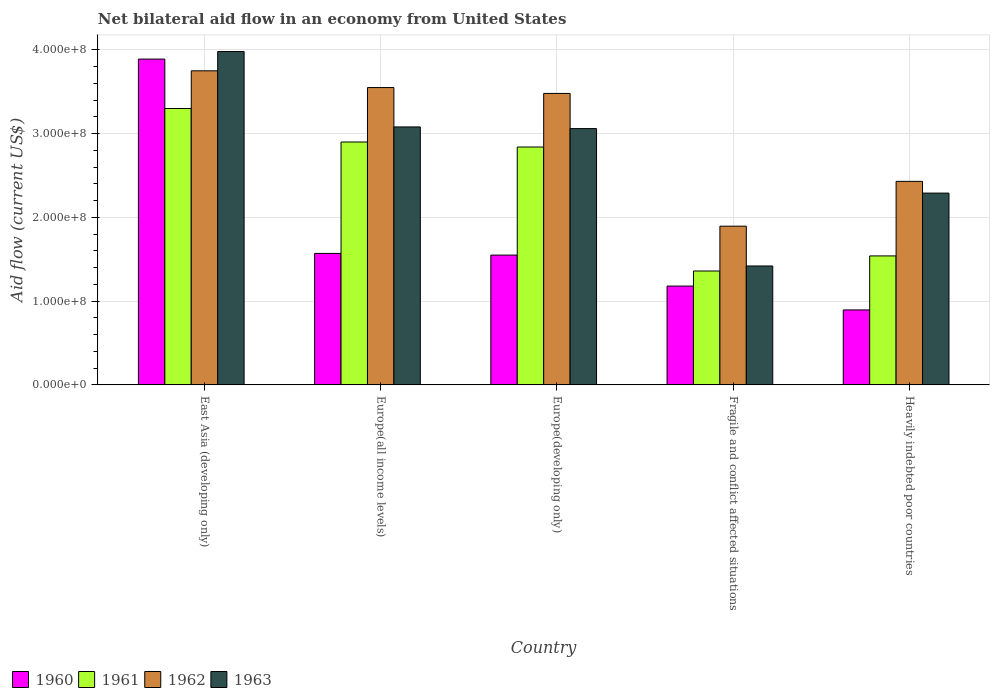How many different coloured bars are there?
Offer a very short reply. 4. How many groups of bars are there?
Keep it short and to the point. 5. Are the number of bars per tick equal to the number of legend labels?
Offer a terse response. Yes. Are the number of bars on each tick of the X-axis equal?
Keep it short and to the point. Yes. How many bars are there on the 1st tick from the left?
Make the answer very short. 4. How many bars are there on the 2nd tick from the right?
Ensure brevity in your answer.  4. What is the label of the 4th group of bars from the left?
Your answer should be very brief. Fragile and conflict affected situations. What is the net bilateral aid flow in 1961 in Europe(developing only)?
Your response must be concise. 2.84e+08. Across all countries, what is the maximum net bilateral aid flow in 1963?
Make the answer very short. 3.98e+08. Across all countries, what is the minimum net bilateral aid flow in 1963?
Provide a succinct answer. 1.42e+08. In which country was the net bilateral aid flow in 1962 maximum?
Make the answer very short. East Asia (developing only). In which country was the net bilateral aid flow in 1960 minimum?
Your response must be concise. Heavily indebted poor countries. What is the total net bilateral aid flow in 1960 in the graph?
Keep it short and to the point. 9.09e+08. What is the difference between the net bilateral aid flow in 1963 in Europe(developing only) and that in Heavily indebted poor countries?
Ensure brevity in your answer.  7.70e+07. What is the difference between the net bilateral aid flow in 1960 in Heavily indebted poor countries and the net bilateral aid flow in 1963 in Europe(developing only)?
Provide a succinct answer. -2.16e+08. What is the average net bilateral aid flow in 1962 per country?
Provide a succinct answer. 3.02e+08. What is the difference between the net bilateral aid flow of/in 1961 and net bilateral aid flow of/in 1960 in Europe(all income levels)?
Ensure brevity in your answer.  1.33e+08. What is the ratio of the net bilateral aid flow in 1961 in Europe(all income levels) to that in Europe(developing only)?
Offer a very short reply. 1.02. Is the difference between the net bilateral aid flow in 1961 in East Asia (developing only) and Heavily indebted poor countries greater than the difference between the net bilateral aid flow in 1960 in East Asia (developing only) and Heavily indebted poor countries?
Offer a very short reply. No. What is the difference between the highest and the second highest net bilateral aid flow in 1961?
Your response must be concise. 4.60e+07. What is the difference between the highest and the lowest net bilateral aid flow in 1963?
Make the answer very short. 2.56e+08. Is the sum of the net bilateral aid flow in 1962 in Europe(all income levels) and Fragile and conflict affected situations greater than the maximum net bilateral aid flow in 1961 across all countries?
Your answer should be compact. Yes. Is it the case that in every country, the sum of the net bilateral aid flow in 1963 and net bilateral aid flow in 1960 is greater than the sum of net bilateral aid flow in 1961 and net bilateral aid flow in 1962?
Keep it short and to the point. No. What does the 3rd bar from the right in Europe(all income levels) represents?
Your answer should be compact. 1961. How many bars are there?
Make the answer very short. 20. Are all the bars in the graph horizontal?
Ensure brevity in your answer.  No. What is the difference between two consecutive major ticks on the Y-axis?
Offer a very short reply. 1.00e+08. Are the values on the major ticks of Y-axis written in scientific E-notation?
Give a very brief answer. Yes. Does the graph contain any zero values?
Provide a short and direct response. No. Does the graph contain grids?
Provide a short and direct response. Yes. Where does the legend appear in the graph?
Offer a very short reply. Bottom left. What is the title of the graph?
Ensure brevity in your answer.  Net bilateral aid flow in an economy from United States. Does "1974" appear as one of the legend labels in the graph?
Give a very brief answer. No. What is the label or title of the X-axis?
Your response must be concise. Country. What is the Aid flow (current US$) of 1960 in East Asia (developing only)?
Ensure brevity in your answer.  3.89e+08. What is the Aid flow (current US$) of 1961 in East Asia (developing only)?
Your answer should be compact. 3.30e+08. What is the Aid flow (current US$) of 1962 in East Asia (developing only)?
Make the answer very short. 3.75e+08. What is the Aid flow (current US$) in 1963 in East Asia (developing only)?
Provide a succinct answer. 3.98e+08. What is the Aid flow (current US$) in 1960 in Europe(all income levels)?
Offer a terse response. 1.57e+08. What is the Aid flow (current US$) in 1961 in Europe(all income levels)?
Your answer should be very brief. 2.90e+08. What is the Aid flow (current US$) in 1962 in Europe(all income levels)?
Your answer should be very brief. 3.55e+08. What is the Aid flow (current US$) of 1963 in Europe(all income levels)?
Provide a short and direct response. 3.08e+08. What is the Aid flow (current US$) of 1960 in Europe(developing only)?
Ensure brevity in your answer.  1.55e+08. What is the Aid flow (current US$) in 1961 in Europe(developing only)?
Your response must be concise. 2.84e+08. What is the Aid flow (current US$) in 1962 in Europe(developing only)?
Offer a terse response. 3.48e+08. What is the Aid flow (current US$) in 1963 in Europe(developing only)?
Keep it short and to the point. 3.06e+08. What is the Aid flow (current US$) in 1960 in Fragile and conflict affected situations?
Ensure brevity in your answer.  1.18e+08. What is the Aid flow (current US$) of 1961 in Fragile and conflict affected situations?
Provide a short and direct response. 1.36e+08. What is the Aid flow (current US$) of 1962 in Fragile and conflict affected situations?
Your response must be concise. 1.90e+08. What is the Aid flow (current US$) of 1963 in Fragile and conflict affected situations?
Provide a succinct answer. 1.42e+08. What is the Aid flow (current US$) in 1960 in Heavily indebted poor countries?
Ensure brevity in your answer.  8.95e+07. What is the Aid flow (current US$) in 1961 in Heavily indebted poor countries?
Provide a short and direct response. 1.54e+08. What is the Aid flow (current US$) of 1962 in Heavily indebted poor countries?
Offer a terse response. 2.43e+08. What is the Aid flow (current US$) in 1963 in Heavily indebted poor countries?
Make the answer very short. 2.29e+08. Across all countries, what is the maximum Aid flow (current US$) of 1960?
Provide a succinct answer. 3.89e+08. Across all countries, what is the maximum Aid flow (current US$) of 1961?
Your answer should be compact. 3.30e+08. Across all countries, what is the maximum Aid flow (current US$) in 1962?
Your answer should be compact. 3.75e+08. Across all countries, what is the maximum Aid flow (current US$) of 1963?
Make the answer very short. 3.98e+08. Across all countries, what is the minimum Aid flow (current US$) in 1960?
Your answer should be very brief. 8.95e+07. Across all countries, what is the minimum Aid flow (current US$) in 1961?
Offer a terse response. 1.36e+08. Across all countries, what is the minimum Aid flow (current US$) in 1962?
Offer a terse response. 1.90e+08. Across all countries, what is the minimum Aid flow (current US$) in 1963?
Your answer should be compact. 1.42e+08. What is the total Aid flow (current US$) in 1960 in the graph?
Make the answer very short. 9.09e+08. What is the total Aid flow (current US$) of 1961 in the graph?
Your response must be concise. 1.19e+09. What is the total Aid flow (current US$) in 1962 in the graph?
Your response must be concise. 1.51e+09. What is the total Aid flow (current US$) in 1963 in the graph?
Give a very brief answer. 1.38e+09. What is the difference between the Aid flow (current US$) in 1960 in East Asia (developing only) and that in Europe(all income levels)?
Your response must be concise. 2.32e+08. What is the difference between the Aid flow (current US$) of 1961 in East Asia (developing only) and that in Europe(all income levels)?
Provide a short and direct response. 4.00e+07. What is the difference between the Aid flow (current US$) of 1962 in East Asia (developing only) and that in Europe(all income levels)?
Keep it short and to the point. 2.00e+07. What is the difference between the Aid flow (current US$) of 1963 in East Asia (developing only) and that in Europe(all income levels)?
Provide a succinct answer. 9.00e+07. What is the difference between the Aid flow (current US$) of 1960 in East Asia (developing only) and that in Europe(developing only)?
Make the answer very short. 2.34e+08. What is the difference between the Aid flow (current US$) in 1961 in East Asia (developing only) and that in Europe(developing only)?
Ensure brevity in your answer.  4.60e+07. What is the difference between the Aid flow (current US$) in 1962 in East Asia (developing only) and that in Europe(developing only)?
Your response must be concise. 2.70e+07. What is the difference between the Aid flow (current US$) of 1963 in East Asia (developing only) and that in Europe(developing only)?
Make the answer very short. 9.20e+07. What is the difference between the Aid flow (current US$) in 1960 in East Asia (developing only) and that in Fragile and conflict affected situations?
Your response must be concise. 2.71e+08. What is the difference between the Aid flow (current US$) in 1961 in East Asia (developing only) and that in Fragile and conflict affected situations?
Your response must be concise. 1.94e+08. What is the difference between the Aid flow (current US$) of 1962 in East Asia (developing only) and that in Fragile and conflict affected situations?
Give a very brief answer. 1.86e+08. What is the difference between the Aid flow (current US$) of 1963 in East Asia (developing only) and that in Fragile and conflict affected situations?
Your answer should be very brief. 2.56e+08. What is the difference between the Aid flow (current US$) in 1960 in East Asia (developing only) and that in Heavily indebted poor countries?
Keep it short and to the point. 2.99e+08. What is the difference between the Aid flow (current US$) of 1961 in East Asia (developing only) and that in Heavily indebted poor countries?
Your answer should be compact. 1.76e+08. What is the difference between the Aid flow (current US$) of 1962 in East Asia (developing only) and that in Heavily indebted poor countries?
Ensure brevity in your answer.  1.32e+08. What is the difference between the Aid flow (current US$) in 1963 in East Asia (developing only) and that in Heavily indebted poor countries?
Your answer should be very brief. 1.69e+08. What is the difference between the Aid flow (current US$) of 1961 in Europe(all income levels) and that in Europe(developing only)?
Your response must be concise. 6.00e+06. What is the difference between the Aid flow (current US$) of 1963 in Europe(all income levels) and that in Europe(developing only)?
Make the answer very short. 2.00e+06. What is the difference between the Aid flow (current US$) in 1960 in Europe(all income levels) and that in Fragile and conflict affected situations?
Make the answer very short. 3.90e+07. What is the difference between the Aid flow (current US$) in 1961 in Europe(all income levels) and that in Fragile and conflict affected situations?
Keep it short and to the point. 1.54e+08. What is the difference between the Aid flow (current US$) in 1962 in Europe(all income levels) and that in Fragile and conflict affected situations?
Your answer should be compact. 1.66e+08. What is the difference between the Aid flow (current US$) in 1963 in Europe(all income levels) and that in Fragile and conflict affected situations?
Make the answer very short. 1.66e+08. What is the difference between the Aid flow (current US$) of 1960 in Europe(all income levels) and that in Heavily indebted poor countries?
Offer a very short reply. 6.75e+07. What is the difference between the Aid flow (current US$) in 1961 in Europe(all income levels) and that in Heavily indebted poor countries?
Offer a terse response. 1.36e+08. What is the difference between the Aid flow (current US$) in 1962 in Europe(all income levels) and that in Heavily indebted poor countries?
Your response must be concise. 1.12e+08. What is the difference between the Aid flow (current US$) of 1963 in Europe(all income levels) and that in Heavily indebted poor countries?
Provide a succinct answer. 7.90e+07. What is the difference between the Aid flow (current US$) in 1960 in Europe(developing only) and that in Fragile and conflict affected situations?
Provide a short and direct response. 3.70e+07. What is the difference between the Aid flow (current US$) in 1961 in Europe(developing only) and that in Fragile and conflict affected situations?
Provide a succinct answer. 1.48e+08. What is the difference between the Aid flow (current US$) of 1962 in Europe(developing only) and that in Fragile and conflict affected situations?
Offer a very short reply. 1.58e+08. What is the difference between the Aid flow (current US$) in 1963 in Europe(developing only) and that in Fragile and conflict affected situations?
Provide a short and direct response. 1.64e+08. What is the difference between the Aid flow (current US$) in 1960 in Europe(developing only) and that in Heavily indebted poor countries?
Offer a terse response. 6.55e+07. What is the difference between the Aid flow (current US$) of 1961 in Europe(developing only) and that in Heavily indebted poor countries?
Your response must be concise. 1.30e+08. What is the difference between the Aid flow (current US$) in 1962 in Europe(developing only) and that in Heavily indebted poor countries?
Your answer should be compact. 1.05e+08. What is the difference between the Aid flow (current US$) of 1963 in Europe(developing only) and that in Heavily indebted poor countries?
Provide a succinct answer. 7.70e+07. What is the difference between the Aid flow (current US$) in 1960 in Fragile and conflict affected situations and that in Heavily indebted poor countries?
Provide a succinct answer. 2.85e+07. What is the difference between the Aid flow (current US$) in 1961 in Fragile and conflict affected situations and that in Heavily indebted poor countries?
Your response must be concise. -1.80e+07. What is the difference between the Aid flow (current US$) of 1962 in Fragile and conflict affected situations and that in Heavily indebted poor countries?
Your answer should be compact. -5.35e+07. What is the difference between the Aid flow (current US$) in 1963 in Fragile and conflict affected situations and that in Heavily indebted poor countries?
Your answer should be compact. -8.70e+07. What is the difference between the Aid flow (current US$) of 1960 in East Asia (developing only) and the Aid flow (current US$) of 1961 in Europe(all income levels)?
Provide a short and direct response. 9.90e+07. What is the difference between the Aid flow (current US$) in 1960 in East Asia (developing only) and the Aid flow (current US$) in 1962 in Europe(all income levels)?
Provide a succinct answer. 3.40e+07. What is the difference between the Aid flow (current US$) of 1960 in East Asia (developing only) and the Aid flow (current US$) of 1963 in Europe(all income levels)?
Your answer should be compact. 8.10e+07. What is the difference between the Aid flow (current US$) of 1961 in East Asia (developing only) and the Aid flow (current US$) of 1962 in Europe(all income levels)?
Keep it short and to the point. -2.50e+07. What is the difference between the Aid flow (current US$) of 1961 in East Asia (developing only) and the Aid flow (current US$) of 1963 in Europe(all income levels)?
Offer a terse response. 2.20e+07. What is the difference between the Aid flow (current US$) of 1962 in East Asia (developing only) and the Aid flow (current US$) of 1963 in Europe(all income levels)?
Ensure brevity in your answer.  6.70e+07. What is the difference between the Aid flow (current US$) in 1960 in East Asia (developing only) and the Aid flow (current US$) in 1961 in Europe(developing only)?
Provide a short and direct response. 1.05e+08. What is the difference between the Aid flow (current US$) in 1960 in East Asia (developing only) and the Aid flow (current US$) in 1962 in Europe(developing only)?
Offer a terse response. 4.10e+07. What is the difference between the Aid flow (current US$) in 1960 in East Asia (developing only) and the Aid flow (current US$) in 1963 in Europe(developing only)?
Provide a short and direct response. 8.30e+07. What is the difference between the Aid flow (current US$) in 1961 in East Asia (developing only) and the Aid flow (current US$) in 1962 in Europe(developing only)?
Your response must be concise. -1.80e+07. What is the difference between the Aid flow (current US$) of 1961 in East Asia (developing only) and the Aid flow (current US$) of 1963 in Europe(developing only)?
Keep it short and to the point. 2.40e+07. What is the difference between the Aid flow (current US$) in 1962 in East Asia (developing only) and the Aid flow (current US$) in 1963 in Europe(developing only)?
Your answer should be compact. 6.90e+07. What is the difference between the Aid flow (current US$) in 1960 in East Asia (developing only) and the Aid flow (current US$) in 1961 in Fragile and conflict affected situations?
Provide a short and direct response. 2.53e+08. What is the difference between the Aid flow (current US$) of 1960 in East Asia (developing only) and the Aid flow (current US$) of 1962 in Fragile and conflict affected situations?
Your response must be concise. 2.00e+08. What is the difference between the Aid flow (current US$) of 1960 in East Asia (developing only) and the Aid flow (current US$) of 1963 in Fragile and conflict affected situations?
Ensure brevity in your answer.  2.47e+08. What is the difference between the Aid flow (current US$) in 1961 in East Asia (developing only) and the Aid flow (current US$) in 1962 in Fragile and conflict affected situations?
Make the answer very short. 1.40e+08. What is the difference between the Aid flow (current US$) in 1961 in East Asia (developing only) and the Aid flow (current US$) in 1963 in Fragile and conflict affected situations?
Your response must be concise. 1.88e+08. What is the difference between the Aid flow (current US$) of 1962 in East Asia (developing only) and the Aid flow (current US$) of 1963 in Fragile and conflict affected situations?
Your answer should be very brief. 2.33e+08. What is the difference between the Aid flow (current US$) of 1960 in East Asia (developing only) and the Aid flow (current US$) of 1961 in Heavily indebted poor countries?
Your answer should be very brief. 2.35e+08. What is the difference between the Aid flow (current US$) in 1960 in East Asia (developing only) and the Aid flow (current US$) in 1962 in Heavily indebted poor countries?
Your answer should be compact. 1.46e+08. What is the difference between the Aid flow (current US$) in 1960 in East Asia (developing only) and the Aid flow (current US$) in 1963 in Heavily indebted poor countries?
Make the answer very short. 1.60e+08. What is the difference between the Aid flow (current US$) of 1961 in East Asia (developing only) and the Aid flow (current US$) of 1962 in Heavily indebted poor countries?
Keep it short and to the point. 8.70e+07. What is the difference between the Aid flow (current US$) of 1961 in East Asia (developing only) and the Aid flow (current US$) of 1963 in Heavily indebted poor countries?
Keep it short and to the point. 1.01e+08. What is the difference between the Aid flow (current US$) in 1962 in East Asia (developing only) and the Aid flow (current US$) in 1963 in Heavily indebted poor countries?
Your response must be concise. 1.46e+08. What is the difference between the Aid flow (current US$) of 1960 in Europe(all income levels) and the Aid flow (current US$) of 1961 in Europe(developing only)?
Your response must be concise. -1.27e+08. What is the difference between the Aid flow (current US$) in 1960 in Europe(all income levels) and the Aid flow (current US$) in 1962 in Europe(developing only)?
Offer a terse response. -1.91e+08. What is the difference between the Aid flow (current US$) of 1960 in Europe(all income levels) and the Aid flow (current US$) of 1963 in Europe(developing only)?
Provide a short and direct response. -1.49e+08. What is the difference between the Aid flow (current US$) in 1961 in Europe(all income levels) and the Aid flow (current US$) in 1962 in Europe(developing only)?
Your answer should be very brief. -5.80e+07. What is the difference between the Aid flow (current US$) of 1961 in Europe(all income levels) and the Aid flow (current US$) of 1963 in Europe(developing only)?
Make the answer very short. -1.60e+07. What is the difference between the Aid flow (current US$) in 1962 in Europe(all income levels) and the Aid flow (current US$) in 1963 in Europe(developing only)?
Give a very brief answer. 4.90e+07. What is the difference between the Aid flow (current US$) in 1960 in Europe(all income levels) and the Aid flow (current US$) in 1961 in Fragile and conflict affected situations?
Keep it short and to the point. 2.10e+07. What is the difference between the Aid flow (current US$) of 1960 in Europe(all income levels) and the Aid flow (current US$) of 1962 in Fragile and conflict affected situations?
Your response must be concise. -3.25e+07. What is the difference between the Aid flow (current US$) of 1960 in Europe(all income levels) and the Aid flow (current US$) of 1963 in Fragile and conflict affected situations?
Provide a short and direct response. 1.50e+07. What is the difference between the Aid flow (current US$) of 1961 in Europe(all income levels) and the Aid flow (current US$) of 1962 in Fragile and conflict affected situations?
Give a very brief answer. 1.00e+08. What is the difference between the Aid flow (current US$) in 1961 in Europe(all income levels) and the Aid flow (current US$) in 1963 in Fragile and conflict affected situations?
Give a very brief answer. 1.48e+08. What is the difference between the Aid flow (current US$) of 1962 in Europe(all income levels) and the Aid flow (current US$) of 1963 in Fragile and conflict affected situations?
Offer a very short reply. 2.13e+08. What is the difference between the Aid flow (current US$) of 1960 in Europe(all income levels) and the Aid flow (current US$) of 1961 in Heavily indebted poor countries?
Offer a very short reply. 3.00e+06. What is the difference between the Aid flow (current US$) of 1960 in Europe(all income levels) and the Aid flow (current US$) of 1962 in Heavily indebted poor countries?
Provide a short and direct response. -8.60e+07. What is the difference between the Aid flow (current US$) in 1960 in Europe(all income levels) and the Aid flow (current US$) in 1963 in Heavily indebted poor countries?
Keep it short and to the point. -7.20e+07. What is the difference between the Aid flow (current US$) of 1961 in Europe(all income levels) and the Aid flow (current US$) of 1962 in Heavily indebted poor countries?
Provide a short and direct response. 4.70e+07. What is the difference between the Aid flow (current US$) of 1961 in Europe(all income levels) and the Aid flow (current US$) of 1963 in Heavily indebted poor countries?
Offer a terse response. 6.10e+07. What is the difference between the Aid flow (current US$) of 1962 in Europe(all income levels) and the Aid flow (current US$) of 1963 in Heavily indebted poor countries?
Provide a short and direct response. 1.26e+08. What is the difference between the Aid flow (current US$) in 1960 in Europe(developing only) and the Aid flow (current US$) in 1961 in Fragile and conflict affected situations?
Offer a terse response. 1.90e+07. What is the difference between the Aid flow (current US$) of 1960 in Europe(developing only) and the Aid flow (current US$) of 1962 in Fragile and conflict affected situations?
Provide a succinct answer. -3.45e+07. What is the difference between the Aid flow (current US$) of 1960 in Europe(developing only) and the Aid flow (current US$) of 1963 in Fragile and conflict affected situations?
Offer a terse response. 1.30e+07. What is the difference between the Aid flow (current US$) of 1961 in Europe(developing only) and the Aid flow (current US$) of 1962 in Fragile and conflict affected situations?
Offer a terse response. 9.45e+07. What is the difference between the Aid flow (current US$) in 1961 in Europe(developing only) and the Aid flow (current US$) in 1963 in Fragile and conflict affected situations?
Offer a very short reply. 1.42e+08. What is the difference between the Aid flow (current US$) in 1962 in Europe(developing only) and the Aid flow (current US$) in 1963 in Fragile and conflict affected situations?
Your answer should be very brief. 2.06e+08. What is the difference between the Aid flow (current US$) in 1960 in Europe(developing only) and the Aid flow (current US$) in 1961 in Heavily indebted poor countries?
Give a very brief answer. 1.00e+06. What is the difference between the Aid flow (current US$) in 1960 in Europe(developing only) and the Aid flow (current US$) in 1962 in Heavily indebted poor countries?
Keep it short and to the point. -8.80e+07. What is the difference between the Aid flow (current US$) of 1960 in Europe(developing only) and the Aid flow (current US$) of 1963 in Heavily indebted poor countries?
Your response must be concise. -7.40e+07. What is the difference between the Aid flow (current US$) in 1961 in Europe(developing only) and the Aid flow (current US$) in 1962 in Heavily indebted poor countries?
Your response must be concise. 4.10e+07. What is the difference between the Aid flow (current US$) in 1961 in Europe(developing only) and the Aid flow (current US$) in 1963 in Heavily indebted poor countries?
Ensure brevity in your answer.  5.50e+07. What is the difference between the Aid flow (current US$) in 1962 in Europe(developing only) and the Aid flow (current US$) in 1963 in Heavily indebted poor countries?
Make the answer very short. 1.19e+08. What is the difference between the Aid flow (current US$) in 1960 in Fragile and conflict affected situations and the Aid flow (current US$) in 1961 in Heavily indebted poor countries?
Offer a very short reply. -3.60e+07. What is the difference between the Aid flow (current US$) in 1960 in Fragile and conflict affected situations and the Aid flow (current US$) in 1962 in Heavily indebted poor countries?
Provide a succinct answer. -1.25e+08. What is the difference between the Aid flow (current US$) of 1960 in Fragile and conflict affected situations and the Aid flow (current US$) of 1963 in Heavily indebted poor countries?
Your response must be concise. -1.11e+08. What is the difference between the Aid flow (current US$) of 1961 in Fragile and conflict affected situations and the Aid flow (current US$) of 1962 in Heavily indebted poor countries?
Provide a succinct answer. -1.07e+08. What is the difference between the Aid flow (current US$) in 1961 in Fragile and conflict affected situations and the Aid flow (current US$) in 1963 in Heavily indebted poor countries?
Provide a succinct answer. -9.30e+07. What is the difference between the Aid flow (current US$) of 1962 in Fragile and conflict affected situations and the Aid flow (current US$) of 1963 in Heavily indebted poor countries?
Offer a terse response. -3.95e+07. What is the average Aid flow (current US$) of 1960 per country?
Your answer should be compact. 1.82e+08. What is the average Aid flow (current US$) in 1961 per country?
Offer a terse response. 2.39e+08. What is the average Aid flow (current US$) of 1962 per country?
Keep it short and to the point. 3.02e+08. What is the average Aid flow (current US$) of 1963 per country?
Ensure brevity in your answer.  2.77e+08. What is the difference between the Aid flow (current US$) of 1960 and Aid flow (current US$) of 1961 in East Asia (developing only)?
Your answer should be compact. 5.90e+07. What is the difference between the Aid flow (current US$) in 1960 and Aid flow (current US$) in 1962 in East Asia (developing only)?
Keep it short and to the point. 1.40e+07. What is the difference between the Aid flow (current US$) in 1960 and Aid flow (current US$) in 1963 in East Asia (developing only)?
Give a very brief answer. -9.00e+06. What is the difference between the Aid flow (current US$) of 1961 and Aid flow (current US$) of 1962 in East Asia (developing only)?
Make the answer very short. -4.50e+07. What is the difference between the Aid flow (current US$) in 1961 and Aid flow (current US$) in 1963 in East Asia (developing only)?
Your answer should be very brief. -6.80e+07. What is the difference between the Aid flow (current US$) of 1962 and Aid flow (current US$) of 1963 in East Asia (developing only)?
Keep it short and to the point. -2.30e+07. What is the difference between the Aid flow (current US$) in 1960 and Aid flow (current US$) in 1961 in Europe(all income levels)?
Ensure brevity in your answer.  -1.33e+08. What is the difference between the Aid flow (current US$) in 1960 and Aid flow (current US$) in 1962 in Europe(all income levels)?
Give a very brief answer. -1.98e+08. What is the difference between the Aid flow (current US$) of 1960 and Aid flow (current US$) of 1963 in Europe(all income levels)?
Offer a terse response. -1.51e+08. What is the difference between the Aid flow (current US$) in 1961 and Aid flow (current US$) in 1962 in Europe(all income levels)?
Offer a terse response. -6.50e+07. What is the difference between the Aid flow (current US$) in 1961 and Aid flow (current US$) in 1963 in Europe(all income levels)?
Your answer should be very brief. -1.80e+07. What is the difference between the Aid flow (current US$) in 1962 and Aid flow (current US$) in 1963 in Europe(all income levels)?
Provide a succinct answer. 4.70e+07. What is the difference between the Aid flow (current US$) of 1960 and Aid flow (current US$) of 1961 in Europe(developing only)?
Your answer should be very brief. -1.29e+08. What is the difference between the Aid flow (current US$) of 1960 and Aid flow (current US$) of 1962 in Europe(developing only)?
Ensure brevity in your answer.  -1.93e+08. What is the difference between the Aid flow (current US$) of 1960 and Aid flow (current US$) of 1963 in Europe(developing only)?
Your answer should be very brief. -1.51e+08. What is the difference between the Aid flow (current US$) of 1961 and Aid flow (current US$) of 1962 in Europe(developing only)?
Your response must be concise. -6.40e+07. What is the difference between the Aid flow (current US$) of 1961 and Aid flow (current US$) of 1963 in Europe(developing only)?
Offer a very short reply. -2.20e+07. What is the difference between the Aid flow (current US$) in 1962 and Aid flow (current US$) in 1963 in Europe(developing only)?
Offer a terse response. 4.20e+07. What is the difference between the Aid flow (current US$) of 1960 and Aid flow (current US$) of 1961 in Fragile and conflict affected situations?
Provide a short and direct response. -1.80e+07. What is the difference between the Aid flow (current US$) in 1960 and Aid flow (current US$) in 1962 in Fragile and conflict affected situations?
Your response must be concise. -7.15e+07. What is the difference between the Aid flow (current US$) of 1960 and Aid flow (current US$) of 1963 in Fragile and conflict affected situations?
Offer a very short reply. -2.40e+07. What is the difference between the Aid flow (current US$) of 1961 and Aid flow (current US$) of 1962 in Fragile and conflict affected situations?
Your response must be concise. -5.35e+07. What is the difference between the Aid flow (current US$) of 1961 and Aid flow (current US$) of 1963 in Fragile and conflict affected situations?
Provide a short and direct response. -6.00e+06. What is the difference between the Aid flow (current US$) in 1962 and Aid flow (current US$) in 1963 in Fragile and conflict affected situations?
Ensure brevity in your answer.  4.75e+07. What is the difference between the Aid flow (current US$) of 1960 and Aid flow (current US$) of 1961 in Heavily indebted poor countries?
Your answer should be very brief. -6.45e+07. What is the difference between the Aid flow (current US$) of 1960 and Aid flow (current US$) of 1962 in Heavily indebted poor countries?
Make the answer very short. -1.53e+08. What is the difference between the Aid flow (current US$) of 1960 and Aid flow (current US$) of 1963 in Heavily indebted poor countries?
Your response must be concise. -1.39e+08. What is the difference between the Aid flow (current US$) in 1961 and Aid flow (current US$) in 1962 in Heavily indebted poor countries?
Make the answer very short. -8.90e+07. What is the difference between the Aid flow (current US$) in 1961 and Aid flow (current US$) in 1963 in Heavily indebted poor countries?
Give a very brief answer. -7.50e+07. What is the difference between the Aid flow (current US$) in 1962 and Aid flow (current US$) in 1963 in Heavily indebted poor countries?
Keep it short and to the point. 1.40e+07. What is the ratio of the Aid flow (current US$) of 1960 in East Asia (developing only) to that in Europe(all income levels)?
Keep it short and to the point. 2.48. What is the ratio of the Aid flow (current US$) of 1961 in East Asia (developing only) to that in Europe(all income levels)?
Provide a succinct answer. 1.14. What is the ratio of the Aid flow (current US$) of 1962 in East Asia (developing only) to that in Europe(all income levels)?
Your response must be concise. 1.06. What is the ratio of the Aid flow (current US$) in 1963 in East Asia (developing only) to that in Europe(all income levels)?
Give a very brief answer. 1.29. What is the ratio of the Aid flow (current US$) of 1960 in East Asia (developing only) to that in Europe(developing only)?
Provide a succinct answer. 2.51. What is the ratio of the Aid flow (current US$) of 1961 in East Asia (developing only) to that in Europe(developing only)?
Your answer should be compact. 1.16. What is the ratio of the Aid flow (current US$) of 1962 in East Asia (developing only) to that in Europe(developing only)?
Keep it short and to the point. 1.08. What is the ratio of the Aid flow (current US$) in 1963 in East Asia (developing only) to that in Europe(developing only)?
Offer a very short reply. 1.3. What is the ratio of the Aid flow (current US$) of 1960 in East Asia (developing only) to that in Fragile and conflict affected situations?
Ensure brevity in your answer.  3.3. What is the ratio of the Aid flow (current US$) in 1961 in East Asia (developing only) to that in Fragile and conflict affected situations?
Provide a succinct answer. 2.43. What is the ratio of the Aid flow (current US$) in 1962 in East Asia (developing only) to that in Fragile and conflict affected situations?
Provide a succinct answer. 1.98. What is the ratio of the Aid flow (current US$) in 1963 in East Asia (developing only) to that in Fragile and conflict affected situations?
Ensure brevity in your answer.  2.8. What is the ratio of the Aid flow (current US$) in 1960 in East Asia (developing only) to that in Heavily indebted poor countries?
Provide a succinct answer. 4.35. What is the ratio of the Aid flow (current US$) of 1961 in East Asia (developing only) to that in Heavily indebted poor countries?
Provide a short and direct response. 2.14. What is the ratio of the Aid flow (current US$) in 1962 in East Asia (developing only) to that in Heavily indebted poor countries?
Offer a terse response. 1.54. What is the ratio of the Aid flow (current US$) of 1963 in East Asia (developing only) to that in Heavily indebted poor countries?
Offer a very short reply. 1.74. What is the ratio of the Aid flow (current US$) in 1960 in Europe(all income levels) to that in Europe(developing only)?
Provide a short and direct response. 1.01. What is the ratio of the Aid flow (current US$) in 1961 in Europe(all income levels) to that in Europe(developing only)?
Your answer should be very brief. 1.02. What is the ratio of the Aid flow (current US$) of 1962 in Europe(all income levels) to that in Europe(developing only)?
Provide a short and direct response. 1.02. What is the ratio of the Aid flow (current US$) in 1963 in Europe(all income levels) to that in Europe(developing only)?
Offer a terse response. 1.01. What is the ratio of the Aid flow (current US$) of 1960 in Europe(all income levels) to that in Fragile and conflict affected situations?
Your answer should be very brief. 1.33. What is the ratio of the Aid flow (current US$) in 1961 in Europe(all income levels) to that in Fragile and conflict affected situations?
Your answer should be very brief. 2.13. What is the ratio of the Aid flow (current US$) in 1962 in Europe(all income levels) to that in Fragile and conflict affected situations?
Offer a terse response. 1.87. What is the ratio of the Aid flow (current US$) of 1963 in Europe(all income levels) to that in Fragile and conflict affected situations?
Your response must be concise. 2.17. What is the ratio of the Aid flow (current US$) of 1960 in Europe(all income levels) to that in Heavily indebted poor countries?
Your answer should be compact. 1.75. What is the ratio of the Aid flow (current US$) of 1961 in Europe(all income levels) to that in Heavily indebted poor countries?
Your response must be concise. 1.88. What is the ratio of the Aid flow (current US$) in 1962 in Europe(all income levels) to that in Heavily indebted poor countries?
Offer a very short reply. 1.46. What is the ratio of the Aid flow (current US$) of 1963 in Europe(all income levels) to that in Heavily indebted poor countries?
Give a very brief answer. 1.34. What is the ratio of the Aid flow (current US$) of 1960 in Europe(developing only) to that in Fragile and conflict affected situations?
Your answer should be very brief. 1.31. What is the ratio of the Aid flow (current US$) of 1961 in Europe(developing only) to that in Fragile and conflict affected situations?
Offer a terse response. 2.09. What is the ratio of the Aid flow (current US$) of 1962 in Europe(developing only) to that in Fragile and conflict affected situations?
Ensure brevity in your answer.  1.84. What is the ratio of the Aid flow (current US$) of 1963 in Europe(developing only) to that in Fragile and conflict affected situations?
Give a very brief answer. 2.15. What is the ratio of the Aid flow (current US$) of 1960 in Europe(developing only) to that in Heavily indebted poor countries?
Give a very brief answer. 1.73. What is the ratio of the Aid flow (current US$) of 1961 in Europe(developing only) to that in Heavily indebted poor countries?
Give a very brief answer. 1.84. What is the ratio of the Aid flow (current US$) of 1962 in Europe(developing only) to that in Heavily indebted poor countries?
Provide a short and direct response. 1.43. What is the ratio of the Aid flow (current US$) in 1963 in Europe(developing only) to that in Heavily indebted poor countries?
Your response must be concise. 1.34. What is the ratio of the Aid flow (current US$) in 1960 in Fragile and conflict affected situations to that in Heavily indebted poor countries?
Your answer should be compact. 1.32. What is the ratio of the Aid flow (current US$) in 1961 in Fragile and conflict affected situations to that in Heavily indebted poor countries?
Your answer should be compact. 0.88. What is the ratio of the Aid flow (current US$) in 1962 in Fragile and conflict affected situations to that in Heavily indebted poor countries?
Give a very brief answer. 0.78. What is the ratio of the Aid flow (current US$) in 1963 in Fragile and conflict affected situations to that in Heavily indebted poor countries?
Offer a very short reply. 0.62. What is the difference between the highest and the second highest Aid flow (current US$) of 1960?
Your response must be concise. 2.32e+08. What is the difference between the highest and the second highest Aid flow (current US$) in 1961?
Make the answer very short. 4.00e+07. What is the difference between the highest and the second highest Aid flow (current US$) of 1962?
Make the answer very short. 2.00e+07. What is the difference between the highest and the second highest Aid flow (current US$) in 1963?
Provide a succinct answer. 9.00e+07. What is the difference between the highest and the lowest Aid flow (current US$) of 1960?
Your answer should be very brief. 2.99e+08. What is the difference between the highest and the lowest Aid flow (current US$) in 1961?
Offer a very short reply. 1.94e+08. What is the difference between the highest and the lowest Aid flow (current US$) in 1962?
Give a very brief answer. 1.86e+08. What is the difference between the highest and the lowest Aid flow (current US$) in 1963?
Provide a succinct answer. 2.56e+08. 